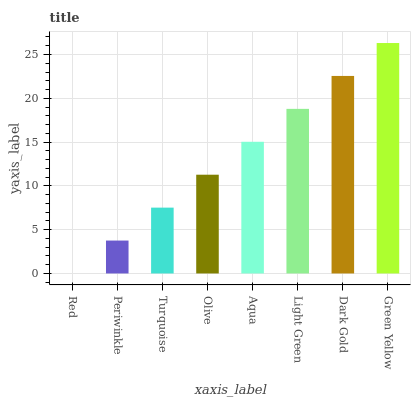Is Red the minimum?
Answer yes or no. Yes. Is Green Yellow the maximum?
Answer yes or no. Yes. Is Periwinkle the minimum?
Answer yes or no. No. Is Periwinkle the maximum?
Answer yes or no. No. Is Periwinkle greater than Red?
Answer yes or no. Yes. Is Red less than Periwinkle?
Answer yes or no. Yes. Is Red greater than Periwinkle?
Answer yes or no. No. Is Periwinkle less than Red?
Answer yes or no. No. Is Aqua the high median?
Answer yes or no. Yes. Is Olive the low median?
Answer yes or no. Yes. Is Green Yellow the high median?
Answer yes or no. No. Is Dark Gold the low median?
Answer yes or no. No. 